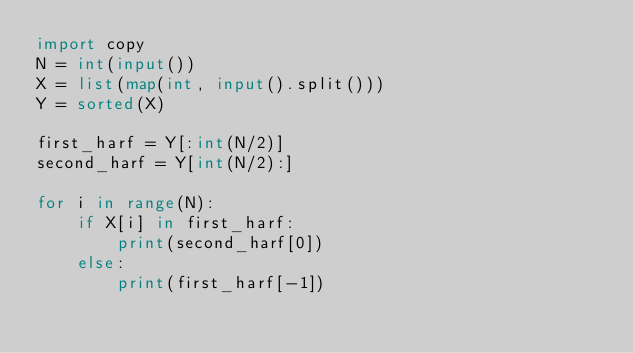Convert code to text. <code><loc_0><loc_0><loc_500><loc_500><_Python_>import copy
N = int(input())
X = list(map(int, input().split()))
Y = sorted(X)

first_harf = Y[:int(N/2)]
second_harf = Y[int(N/2):]

for i in range(N):
    if X[i] in first_harf:
        print(second_harf[0])
    else:
        print(first_harf[-1])
</code> 